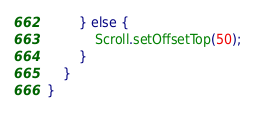<code> <loc_0><loc_0><loc_500><loc_500><_TypeScript_>		} else {
			Scroll.setOffsetTop(50);
		}
	}
}
</code> 